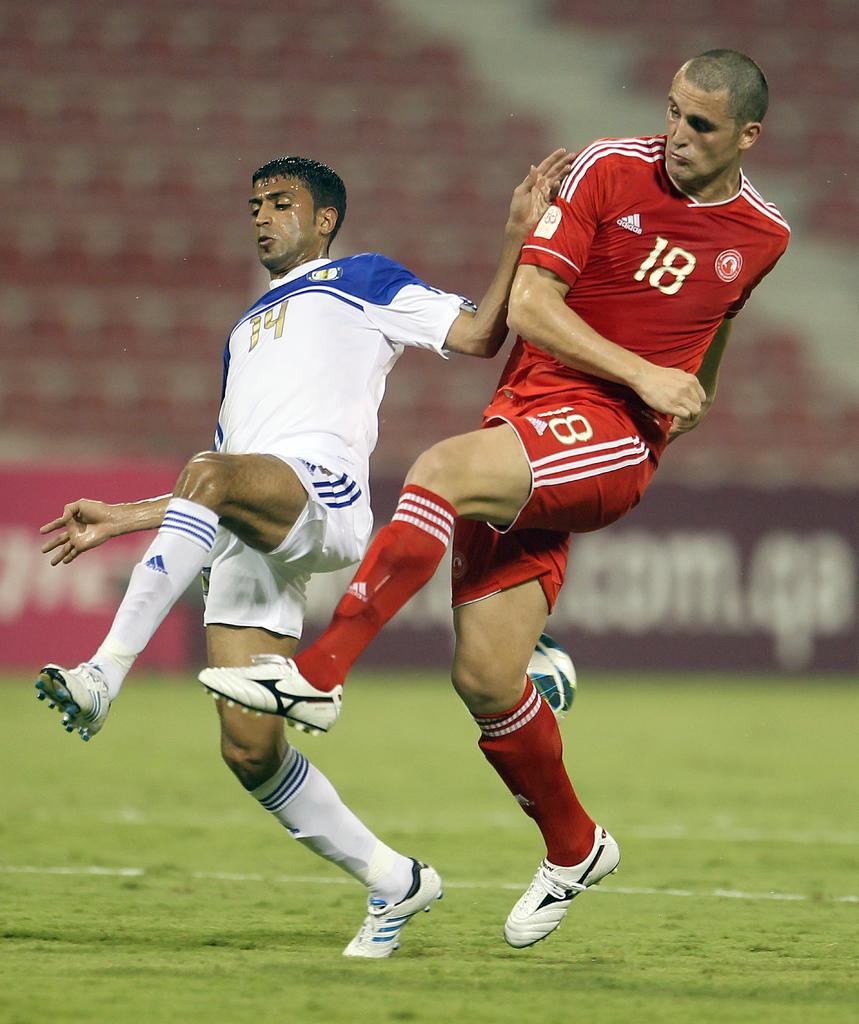<image>
Summarize the visual content of the image. Players 14 and 18 from opposing soccer teams go for the ball. 